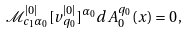<formula> <loc_0><loc_0><loc_500><loc_500>\mathcal { M } _ { c _ { 1 } \alpha _ { 0 } } ^ { | 0 | } [ v ^ { | 0 | } _ { q _ { 0 } } ] ^ { \alpha _ { 0 } } d A _ { 0 } ^ { q _ { 0 } } ( x ) = 0 \, ,</formula> 